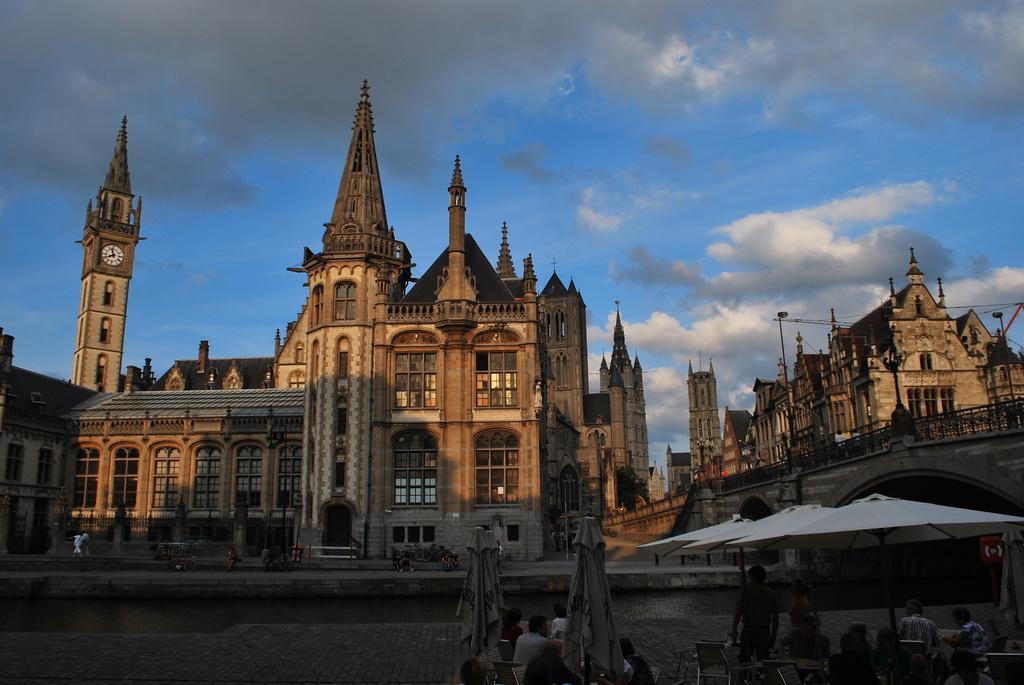Can you describe this image briefly? In this image I can see at the bottom few persons are sitting on the chairs. On the right side there are umbrellas, in the middle there are very big buildings. At the top it is the blue color sky. 